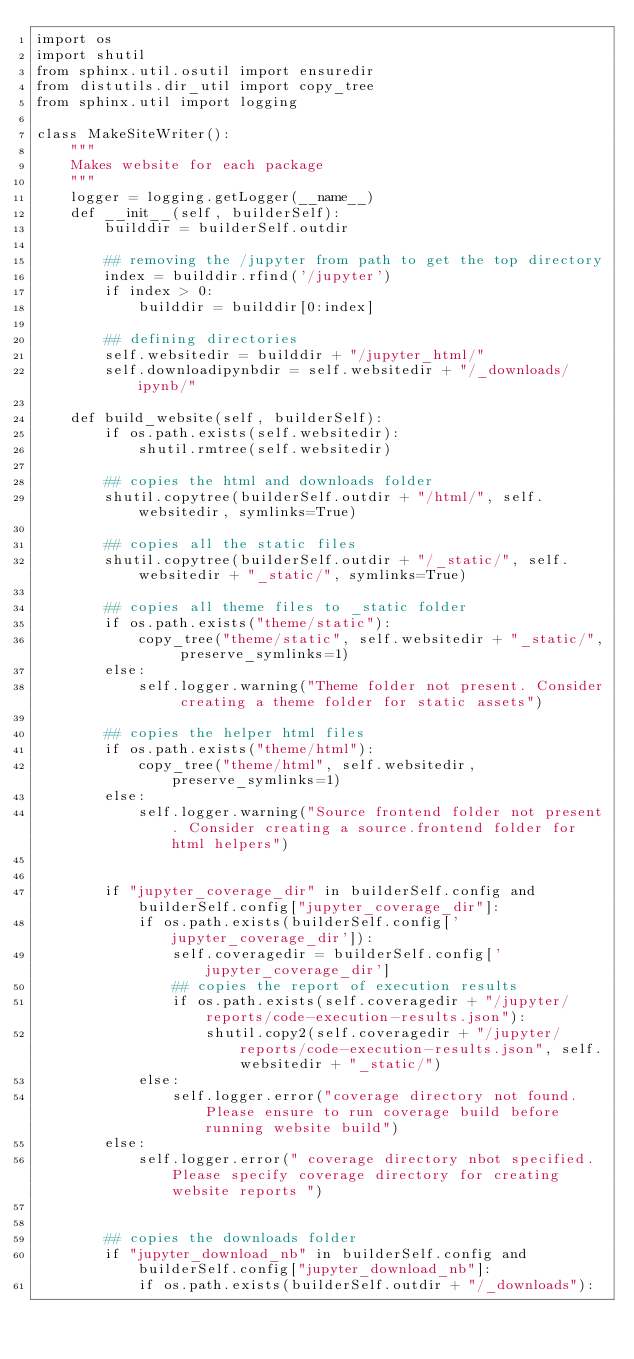Convert code to text. <code><loc_0><loc_0><loc_500><loc_500><_Python_>import os
import shutil
from sphinx.util.osutil import ensuredir
from distutils.dir_util import copy_tree
from sphinx.util import logging

class MakeSiteWriter():
    """
    Makes website for each package
    """
    logger = logging.getLogger(__name__)
    def __init__(self, builderSelf):
        builddir = builderSelf.outdir

        ## removing the /jupyter from path to get the top directory
        index = builddir.rfind('/jupyter')
        if index > 0:
            builddir = builddir[0:index]    
        
        ## defining directories
        self.websitedir = builddir + "/jupyter_html/"
        self.downloadipynbdir = self.websitedir + "/_downloads/ipynb/"

    def build_website(self, builderSelf):
        if os.path.exists(self.websitedir):
            shutil.rmtree(self.websitedir)

        ## copies the html and downloads folder
        shutil.copytree(builderSelf.outdir + "/html/", self.websitedir, symlinks=True)

        ## copies all the static files
        shutil.copytree(builderSelf.outdir + "/_static/", self.websitedir + "_static/", symlinks=True)

        ## copies all theme files to _static folder 
        if os.path.exists("theme/static"):
            copy_tree("theme/static", self.websitedir + "_static/", preserve_symlinks=1)
        else:
            self.logger.warning("Theme folder not present. Consider creating a theme folder for static assets")

        ## copies the helper html files 
        if os.path.exists("theme/html"):
            copy_tree("theme/html", self.websitedir, preserve_symlinks=1)
        else:
            self.logger.warning("Source frontend folder not present. Consider creating a source.frontend folder for html helpers")


        if "jupyter_coverage_dir" in builderSelf.config and builderSelf.config["jupyter_coverage_dir"]:
            if os.path.exists(builderSelf.config['jupyter_coverage_dir']):
                self.coveragedir = builderSelf.config['jupyter_coverage_dir']
                ## copies the report of execution results
                if os.path.exists(self.coveragedir + "/jupyter/reports/code-execution-results.json"):
                    shutil.copy2(self.coveragedir + "/jupyter/reports/code-execution-results.json", self.websitedir + "_static/")
            else:
                self.logger.error("coverage directory not found. Please ensure to run coverage build before running website build")
        else:
            self.logger.error(" coverage directory nbot specified. Please specify coverage directory for creating website reports ")

        
        ## copies the downloads folder
        if "jupyter_download_nb" in builderSelf.config and builderSelf.config["jupyter_download_nb"]:
            if os.path.exists(builderSelf.outdir + "/_downloads"):</code> 